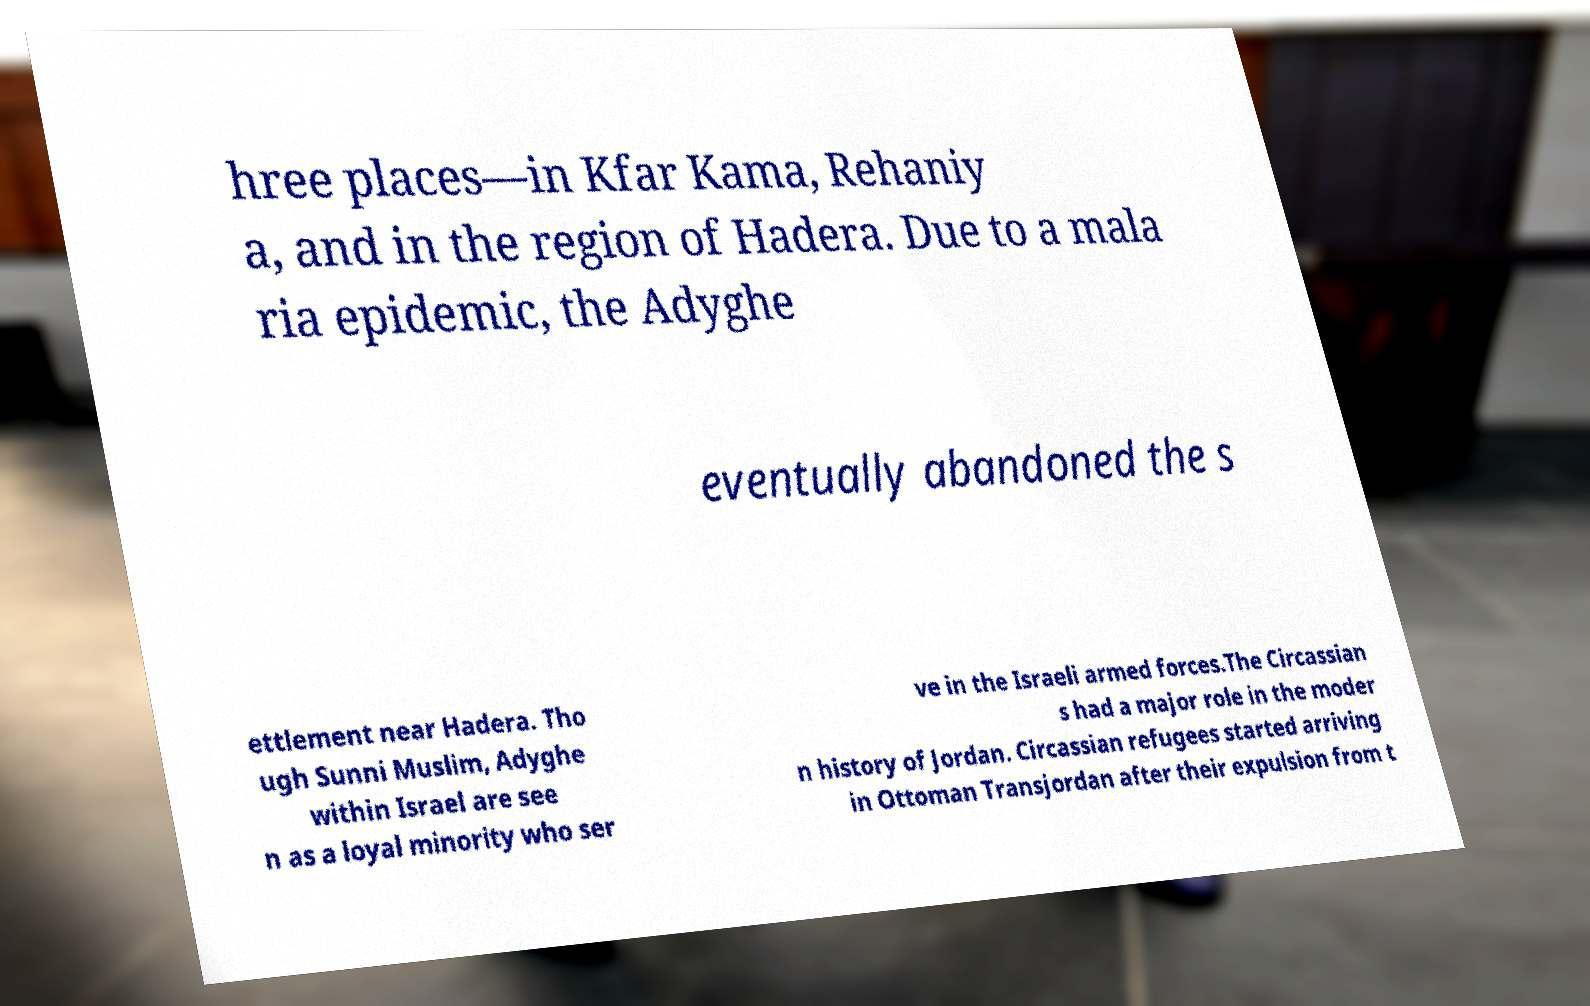I need the written content from this picture converted into text. Can you do that? hree places—in Kfar Kama, Rehaniy a, and in the region of Hadera. Due to a mala ria epidemic, the Adyghe eventually abandoned the s ettlement near Hadera. Tho ugh Sunni Muslim, Adyghe within Israel are see n as a loyal minority who ser ve in the Israeli armed forces.The Circassian s had a major role in the moder n history of Jordan. Circassian refugees started arriving in Ottoman Transjordan after their expulsion from t 